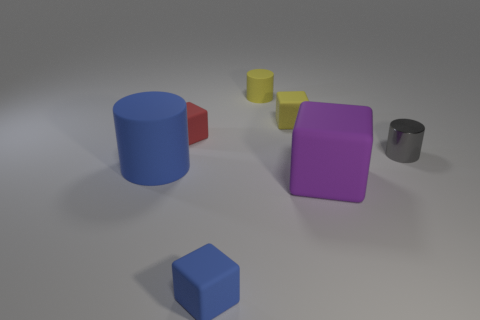Subtract all yellow matte blocks. How many blocks are left? 3 Add 1 big purple matte cubes. How many objects exist? 8 Subtract all purple blocks. How many blocks are left? 3 Subtract 2 cylinders. How many cylinders are left? 1 Subtract all yellow balls. How many blue cubes are left? 1 Add 4 small gray things. How many small gray things are left? 5 Add 2 yellow objects. How many yellow objects exist? 4 Subtract 0 green blocks. How many objects are left? 7 Subtract all cubes. How many objects are left? 3 Subtract all red cylinders. Subtract all red blocks. How many cylinders are left? 3 